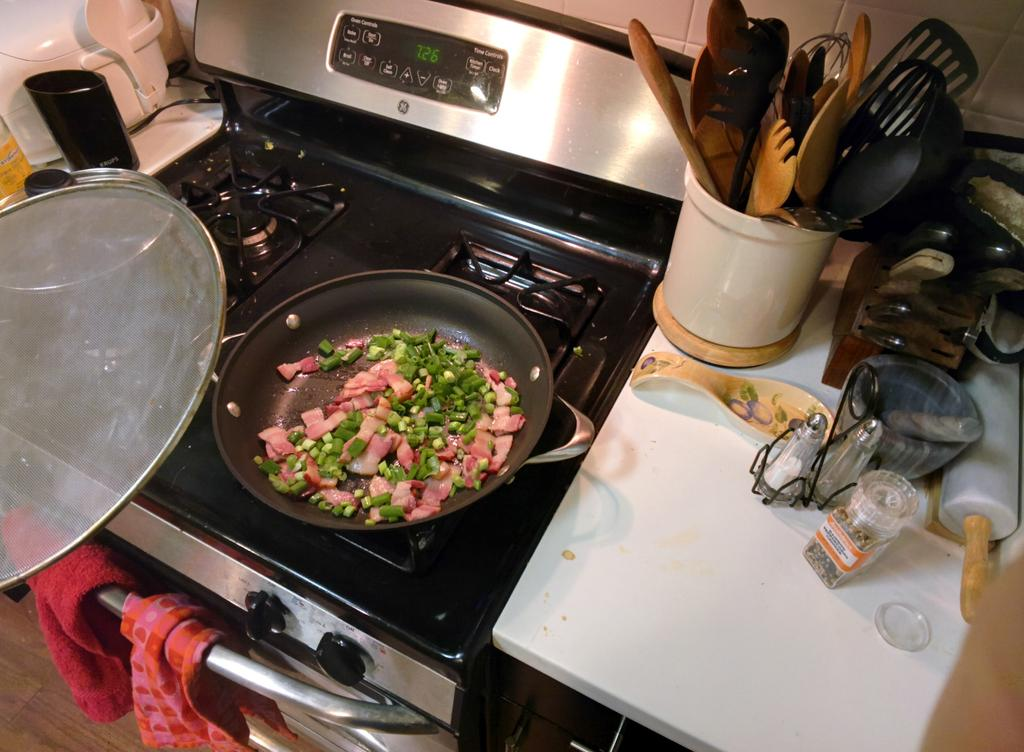<image>
Give a short and clear explanation of the subsequent image. A black and silver stove with 7:26 displayed on the screen. 